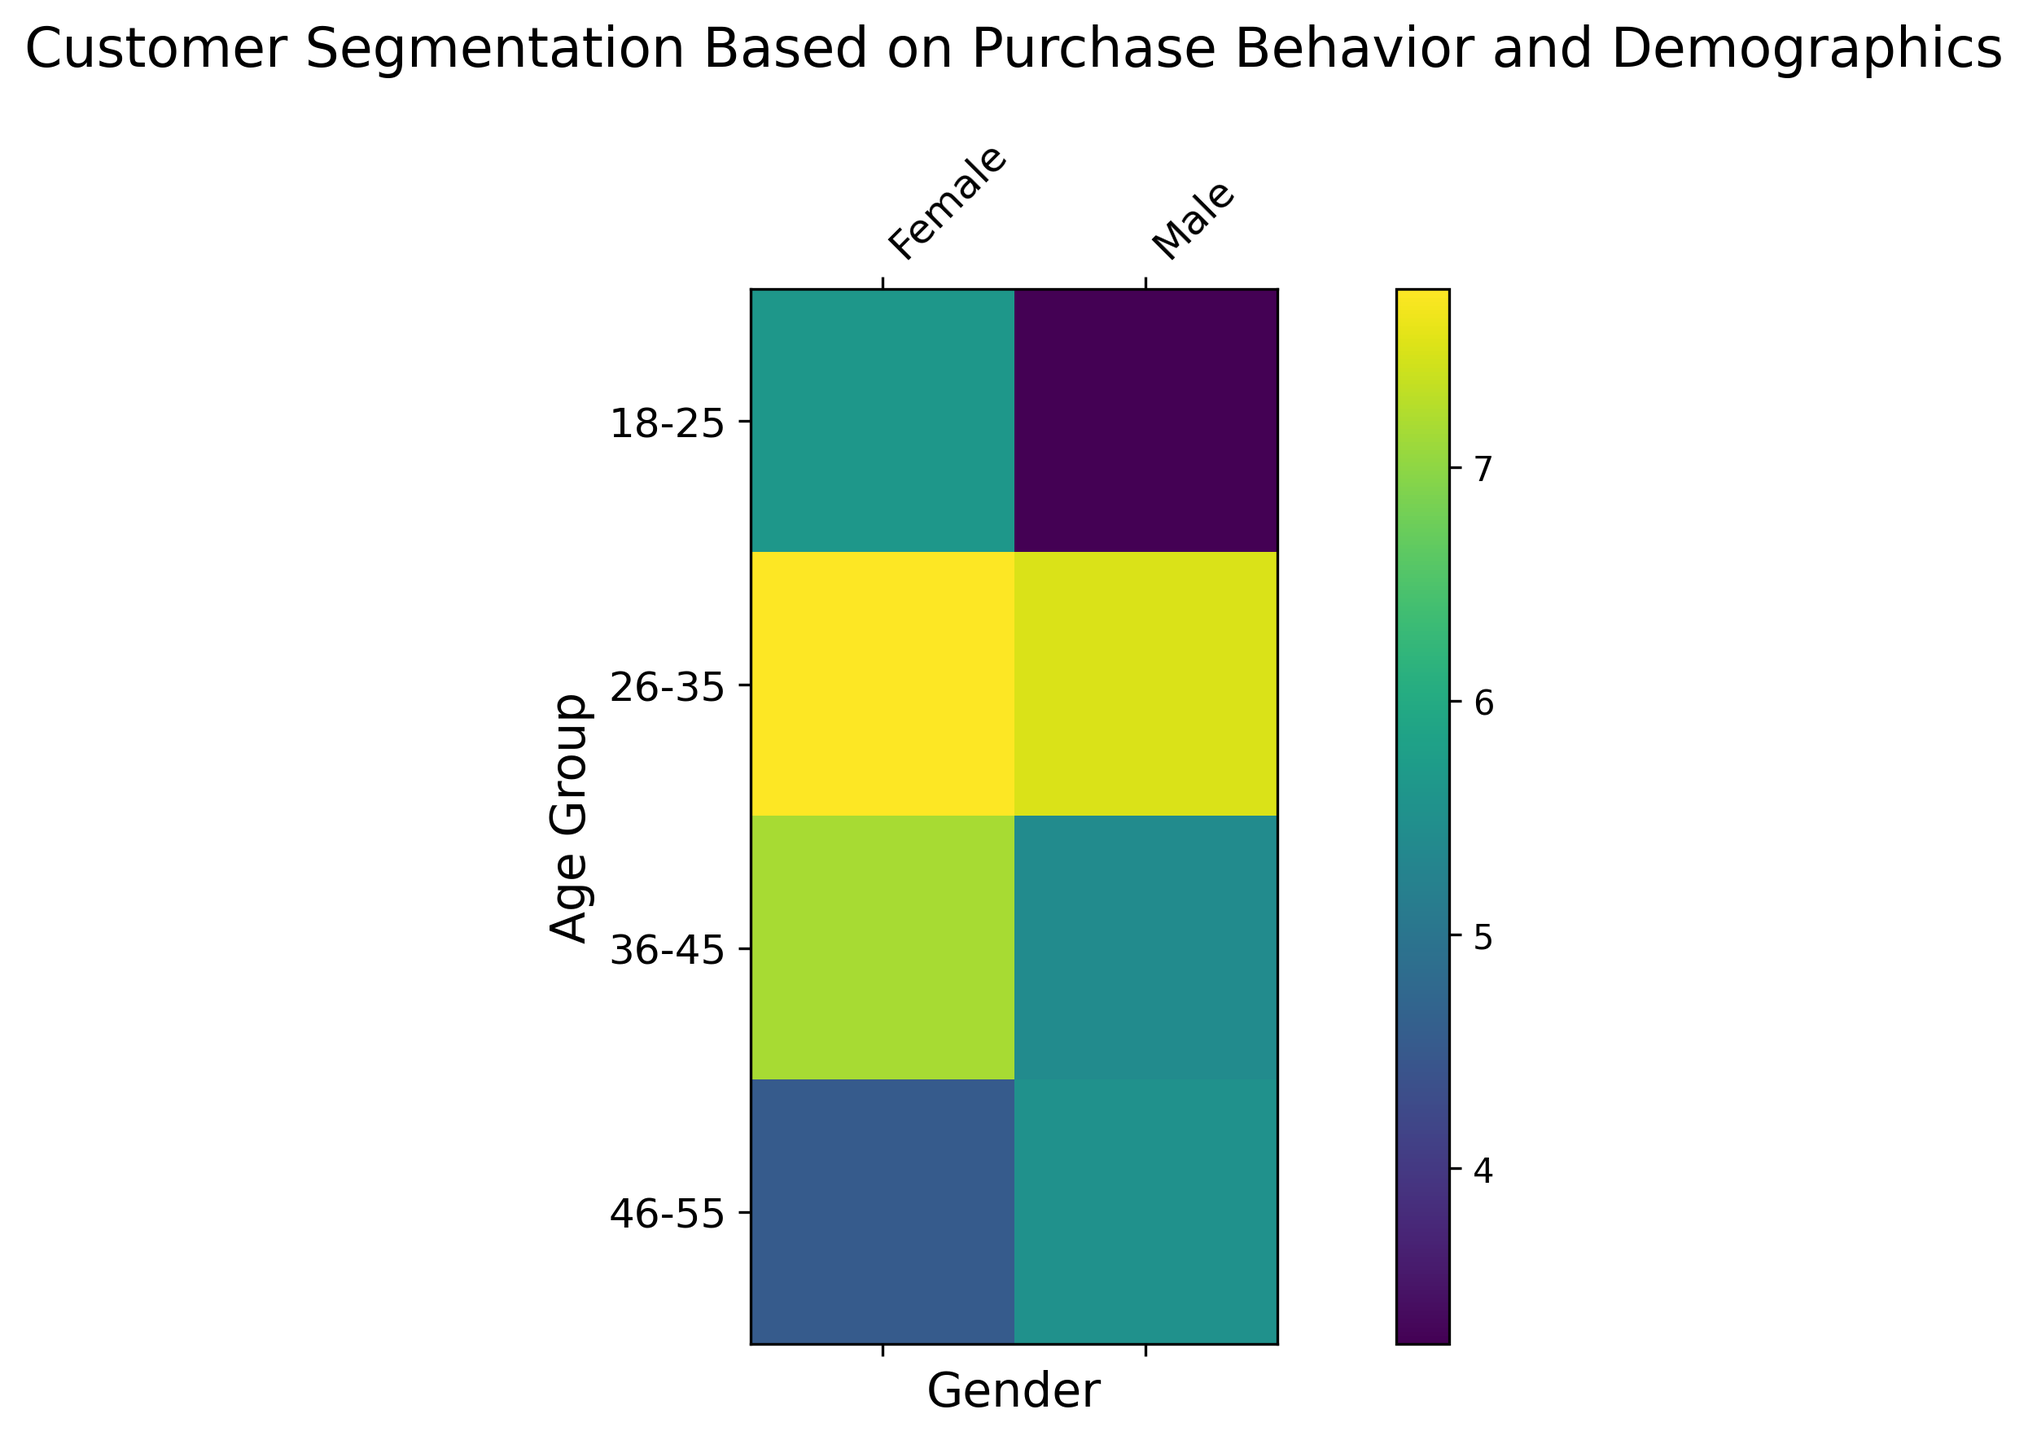What is the average segmentation score for males aged 36-45? Look at the heatmap and find the cell where the Gender is Male and Age Group is 36-45. The value in this cell represents the average Segmentation Score for that group. In this plot, it is 5.4
Answer: 5.4 Which gender has a higher average segmentation score in the 26-35 age group? Compare the segmentation scores for males and females in the 26-35 age group on the heatmap. The female segmentation score is higher (7.76 vs. 5.96).
Answer: Female Which age group has the highest average segmentation score for females? Look at the row for each female age group on the heatmap and determine which row has the highest value. The 26-35 age group has the highest average segmentation score of 7.76.
Answer: 26-35 Compare the average segmentation scores between males and females aged 18-25. Which group has the higher score? Check the cells corresponding to the 18-25 age group for both genders. Females have a higher score (5.66 compared to 3.0 for males).
Answer: Female Is the average segmentation score for males in the 46-55 age group above or below 5? Look at the cell for males aged 46-55 on the heatmap, which is 5.14. This is above 5.
Answer: Above What is the combined average segmentation score for females aged 36-45 and 46-55? Find the segmentation scores for females aged 36-45 (6.625) and 46-55 (5.38), then calculate the average of these two values: (6.625 + 5.38)/2 = 6.0025.
Answer: 6.0025 Which age group shows the greatest difference in segmentation score between males and females? Examine the differences between males and females in each age group. The largest difference occurs in the 26-35 age group: females (7.76) - males (5.96) = 1.8.
Answer: 26-35 What is the average segmentation score for each gender across all age groups? First, find the values for each age group and gender, then calculate the averages for males (5.5) and females (6.42696). The averages are calculated by summing the scores for each gender and dividing by the number of age groups.
Answer: Male: 5.5, Female: 6.427 Is the segmentation score for females aged 18-25 closer to the segmentation score for males aged 26-35 or the score for males aged 36-45? Compare the female score for 18-25 (5.66) to the male scores for 26-35 (5.96) and 36-45 (5.36). The value 5.66 is closer to 5.96.
Answer: Males aged 26-35 